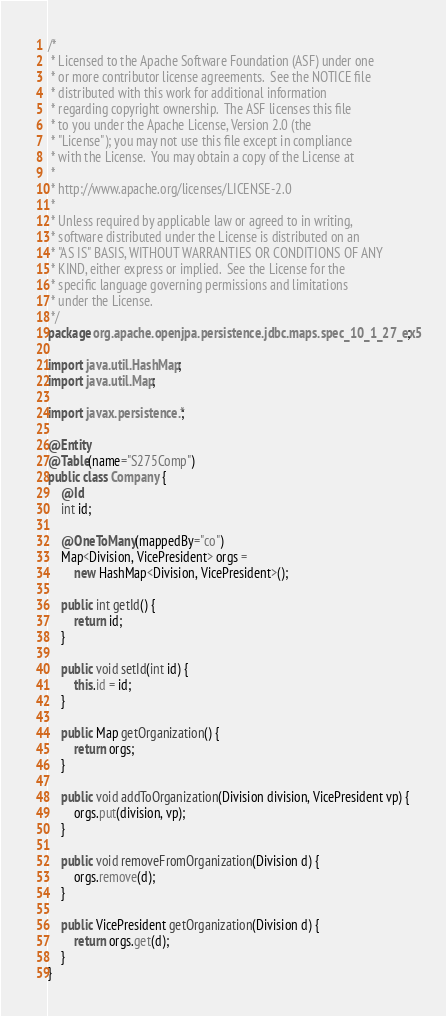<code> <loc_0><loc_0><loc_500><loc_500><_Java_>/*
 * Licensed to the Apache Software Foundation (ASF) under one
 * or more contributor license agreements.  See the NOTICE file
 * distributed with this work for additional information
 * regarding copyright ownership.  The ASF licenses this file
 * to you under the Apache License, Version 2.0 (the
 * "License"); you may not use this file except in compliance
 * with the License.  You may obtain a copy of the License at
 *
 * http://www.apache.org/licenses/LICENSE-2.0
 *
 * Unless required by applicable law or agreed to in writing,
 * software distributed under the License is distributed on an
 * "AS IS" BASIS, WITHOUT WARRANTIES OR CONDITIONS OF ANY
 * KIND, either express or implied.  See the License for the
 * specific language governing permissions and limitations
 * under the License.    
 */
package org.apache.openjpa.persistence.jdbc.maps.spec_10_1_27_ex5;

import java.util.HashMap;
import java.util.Map;

import javax.persistence.*;

@Entity
@Table(name="S275Comp")
public class Company {
    @Id
    int id;

    @OneToMany(mappedBy="co")
    Map<Division, VicePresident> orgs =
        new HashMap<Division, VicePresident>();

    public int getId() {
        return id;
    }

    public void setId(int id) {
        this.id = id;
    }

    public Map getOrganization() {
        return orgs;
    }

    public void addToOrganization(Division division, VicePresident vp) {
        orgs.put(division, vp);
    }

    public void removeFromOrganization(Division d) {
        orgs.remove(d);
    }

    public VicePresident getOrganization(Division d) {
        return orgs.get(d);
    }
}
</code> 